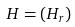<formula> <loc_0><loc_0><loc_500><loc_500>H = ( H _ { r } )</formula> 